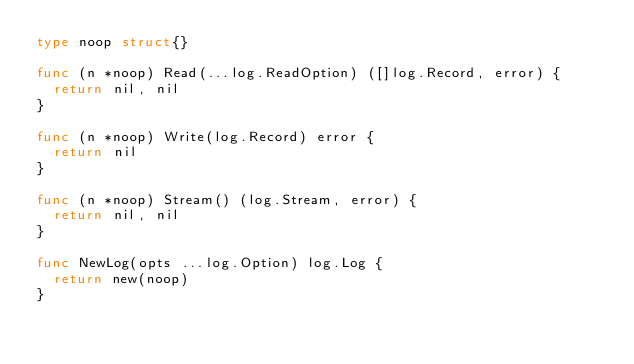Convert code to text. <code><loc_0><loc_0><loc_500><loc_500><_Go_>type noop struct{}

func (n *noop) Read(...log.ReadOption) ([]log.Record, error) {
	return nil, nil
}

func (n *noop) Write(log.Record) error {
	return nil
}

func (n *noop) Stream() (log.Stream, error) {
	return nil, nil
}

func NewLog(opts ...log.Option) log.Log {
	return new(noop)
}
</code> 